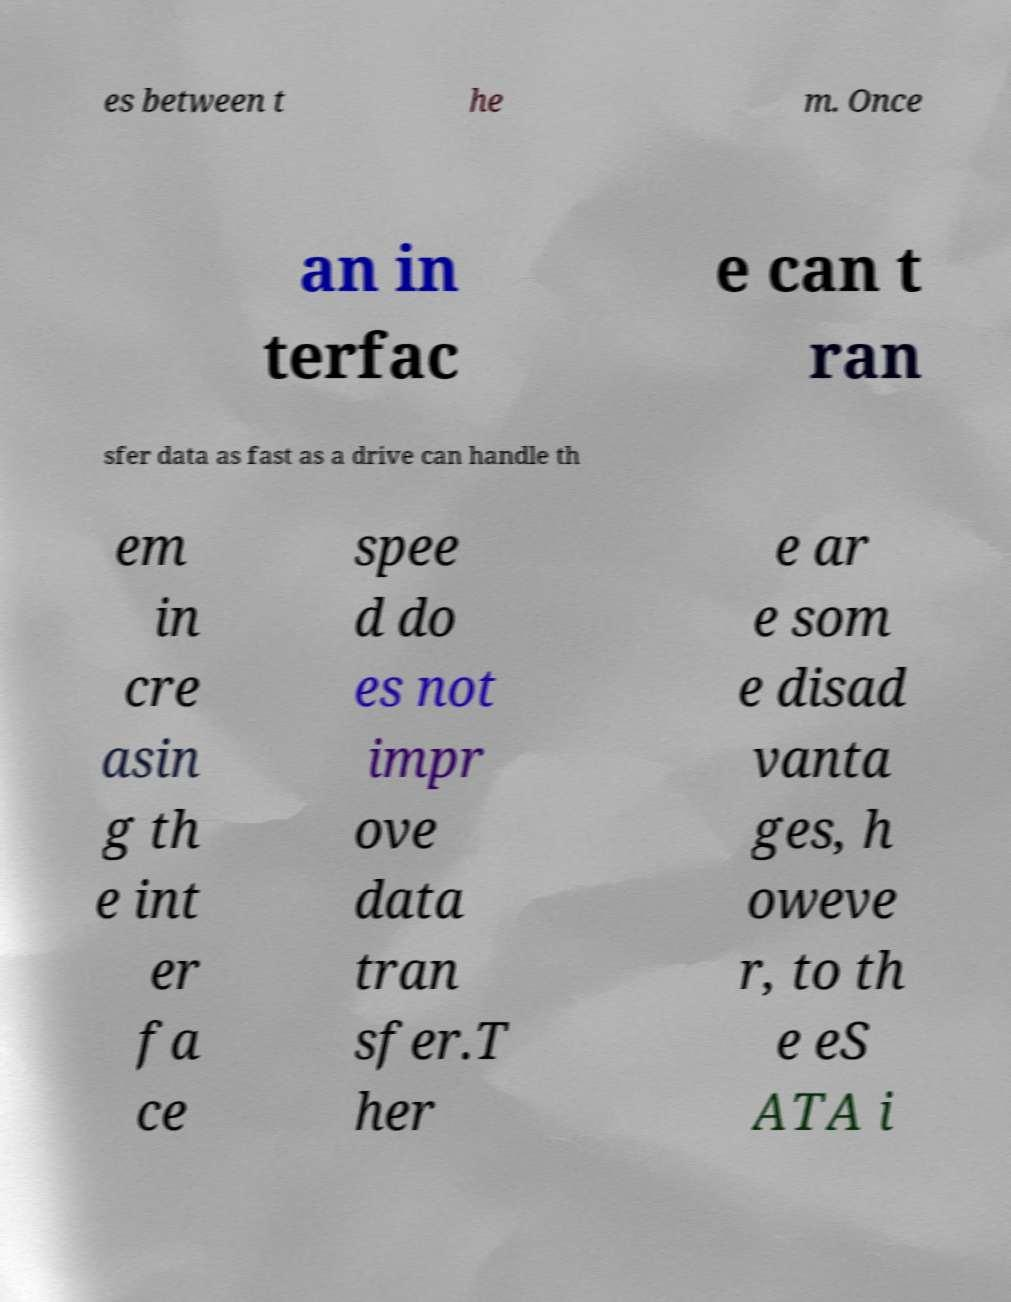Can you accurately transcribe the text from the provided image for me? es between t he m. Once an in terfac e can t ran sfer data as fast as a drive can handle th em in cre asin g th e int er fa ce spee d do es not impr ove data tran sfer.T her e ar e som e disad vanta ges, h oweve r, to th e eS ATA i 